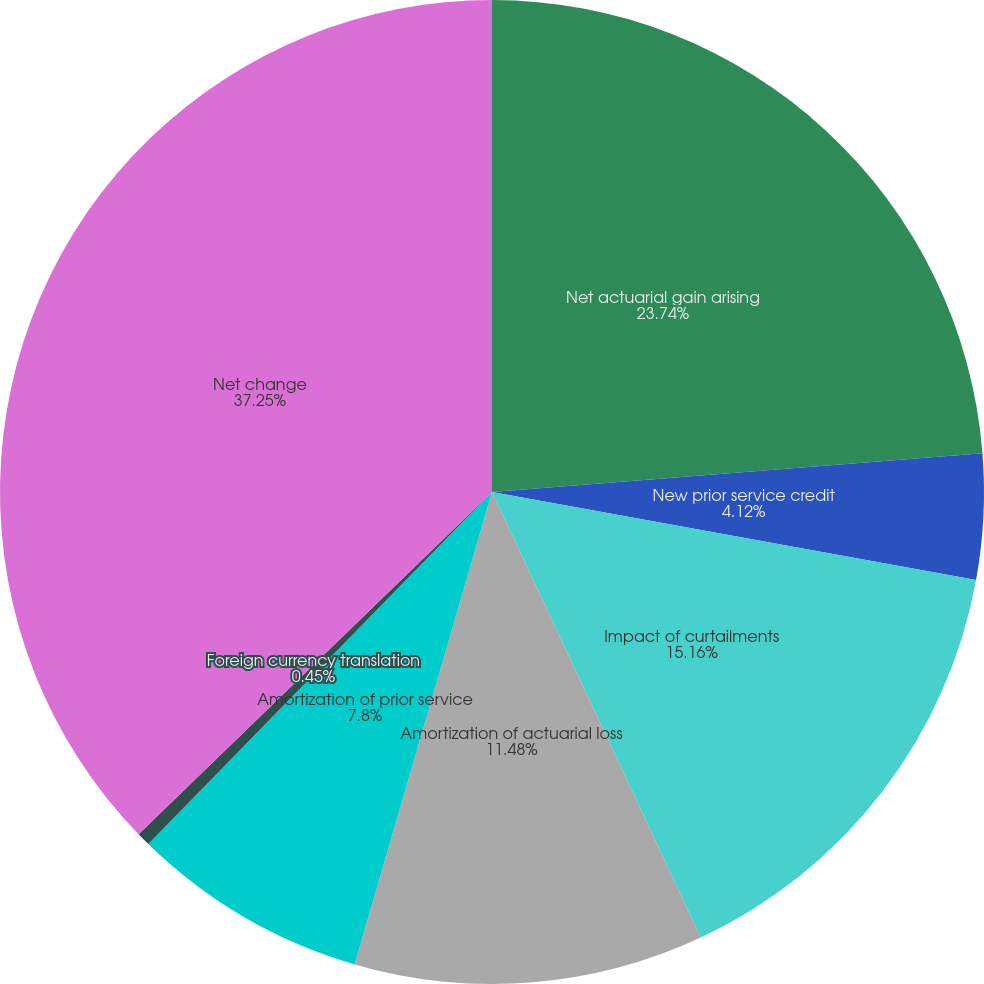Convert chart to OTSL. <chart><loc_0><loc_0><loc_500><loc_500><pie_chart><fcel>Net actuarial gain arising<fcel>New prior service credit<fcel>Impact of curtailments<fcel>Amortization of actuarial loss<fcel>Amortization of prior service<fcel>Foreign currency translation<fcel>Net change<nl><fcel>23.74%<fcel>4.12%<fcel>15.16%<fcel>11.48%<fcel>7.8%<fcel>0.45%<fcel>37.24%<nl></chart> 